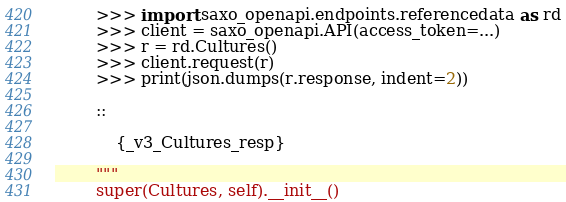Convert code to text. <code><loc_0><loc_0><loc_500><loc_500><_Python_>        >>> import saxo_openapi.endpoints.referencedata as rd
        >>> client = saxo_openapi.API(access_token=...)
        >>> r = rd.Cultures()
        >>> client.request(r)
        >>> print(json.dumps(r.response, indent=2))

        ::

            {_v3_Cultures_resp}

        """
        super(Cultures, self).__init__()
</code> 